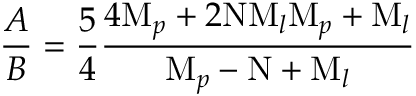<formula> <loc_0><loc_0><loc_500><loc_500>{ \frac { A } { B } } = { \frac { 5 } { 4 } } { \frac { 4 M _ { p } + 2 N M _ { l } M _ { p } + M _ { l } } { M _ { p } - N + M _ { l } } }</formula> 